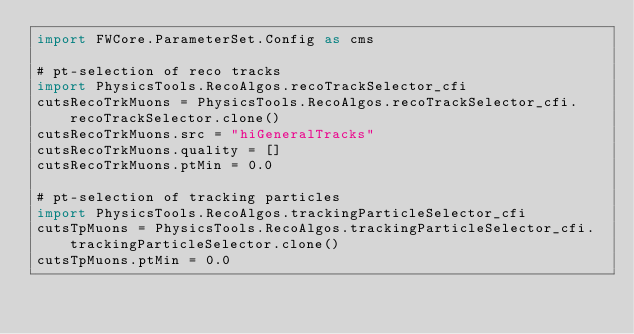Convert code to text. <code><loc_0><loc_0><loc_500><loc_500><_Python_>import FWCore.ParameterSet.Config as cms

# pt-selection of reco tracks
import PhysicsTools.RecoAlgos.recoTrackSelector_cfi
cutsRecoTrkMuons = PhysicsTools.RecoAlgos.recoTrackSelector_cfi.recoTrackSelector.clone()
cutsRecoTrkMuons.src = "hiGeneralTracks"
cutsRecoTrkMuons.quality = []
cutsRecoTrkMuons.ptMin = 0.0

# pt-selection of tracking particles
import PhysicsTools.RecoAlgos.trackingParticleSelector_cfi
cutsTpMuons = PhysicsTools.RecoAlgos.trackingParticleSelector_cfi.trackingParticleSelector.clone()
cutsTpMuons.ptMin = 0.0

</code> 